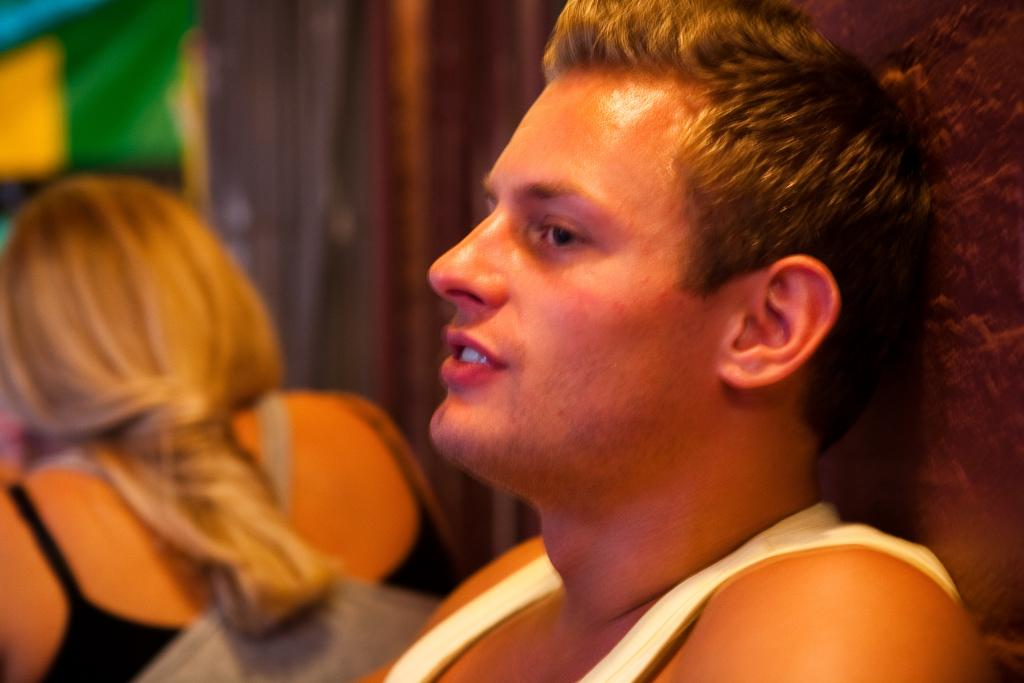What can be observed about the background of the image? The background portion of the picture is blurred. Can you describe the person in the image? There is a person with light brown hair in the image. Where is the man located in the image? There is a man on the right side of the image. What type of door can be seen in the image? There is no door present in the image. Is the slope visible in the image? There is no slope visible in the image. Can you tell me how many teeth the person in the image has? We cannot determine the number of teeth the person in the image has, as their mouth is not visible. 